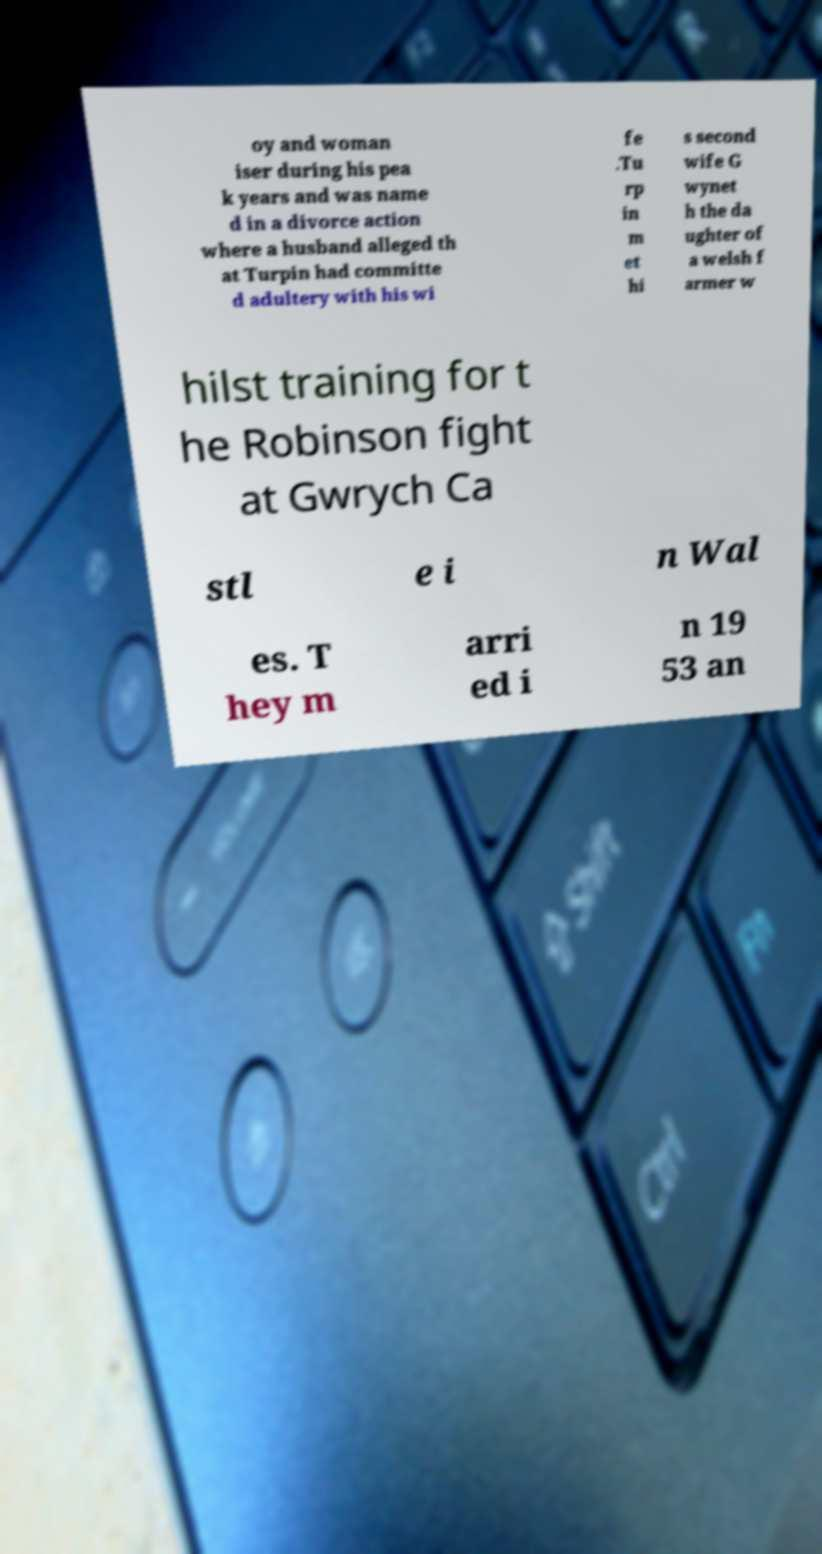I need the written content from this picture converted into text. Can you do that? oy and woman iser during his pea k years and was name d in a divorce action where a husband alleged th at Turpin had committe d adultery with his wi fe .Tu rp in m et hi s second wife G wynet h the da ughter of a welsh f armer w hilst training for t he Robinson fight at Gwrych Ca stl e i n Wal es. T hey m arri ed i n 19 53 an 